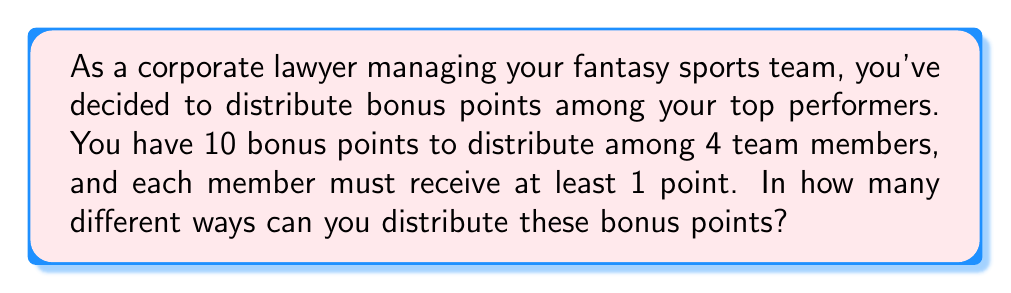Could you help me with this problem? This problem can be solved using the concept of stars and bars (also known as balls and urns).

1) First, we need to understand that this is a problem of distributing indistinguishable objects (bonus points) into distinct containers (team members).

2) We have 10 bonus points to distribute. However, since each member must receive at least 1 point, we can first give each member 1 point. This leaves us with 6 points to distribute (10 - 4 = 6).

3) Now, we need to find the number of ways to distribute 6 indistinguishable objects into 4 distinct containers.

4) The formula for this scenario is:

   $${n+k-1 \choose k-1}$$

   Where n is the number of objects and k is the number of containers.

5) In our case, n = 6 and k = 4. So we need to calculate:

   $${6+4-1 \choose 4-1} = {9 \choose 3}$$

6) We can calculate this as follows:

   $${9 \choose 3} = \frac{9!}{3!(9-3)!} = \frac{9!}{3!6!}$$

7) Expanding this:

   $$\frac{9 * 8 * 7 * 6!}{(3 * 2 * 1) * 6!} = \frac{504}{6} = 84$$

Therefore, there are 84 different ways to distribute the bonus points.
Answer: 84 